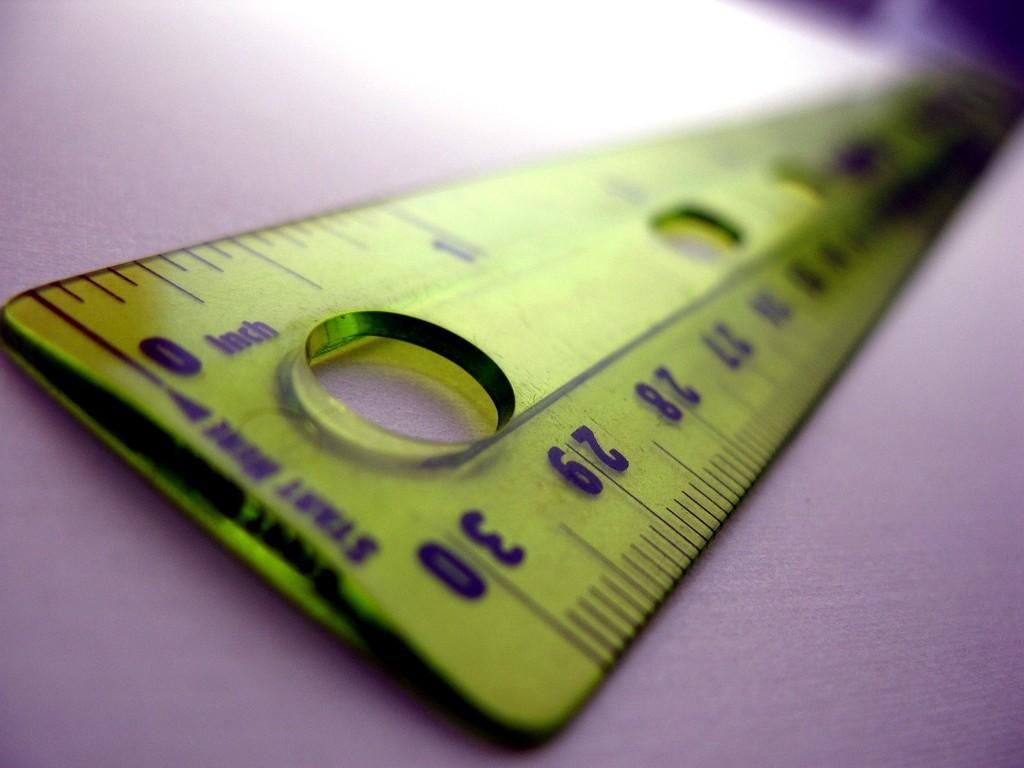What color is the plank in the image? The plank in the image is purple. What other object can be seen in the image? There is a green scale in the image. What feature does the scale have? The scale has measurement readings on it. How many screws are visible on the purple plank in the image? There are no screws visible on the purple plank in the image. Can you see a fly sitting on the green scale in the image? There is no fly present in the image. 